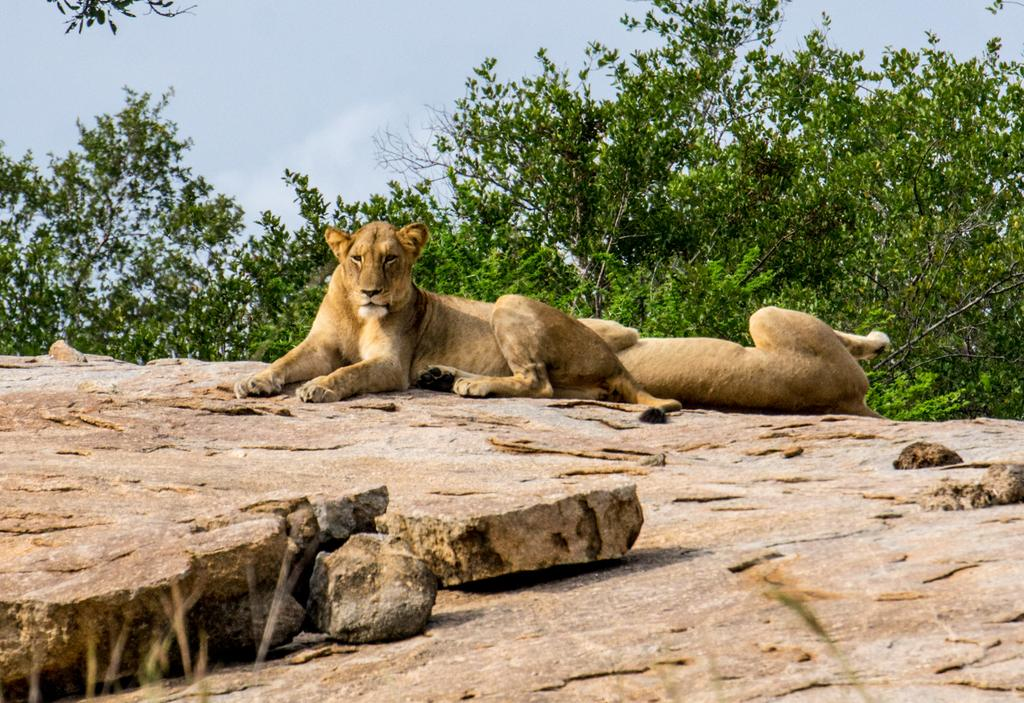What animals are present in the image? There are two lionesses in the image. Where are the lionesses located? The lionesses are sitting on a rock. What can be seen in the background of the image? There are trees visible in the background of the image. What type of curtain can be seen hanging from the trees in the image? There are no curtains present in the image; it features two lionesses sitting on a rock with trees visible in the background. 